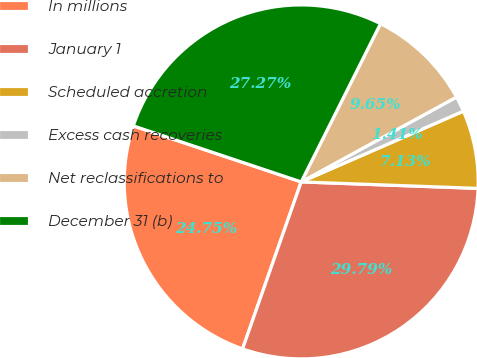<chart> <loc_0><loc_0><loc_500><loc_500><pie_chart><fcel>In millions<fcel>January 1<fcel>Scheduled accretion<fcel>Excess cash recoveries<fcel>Net reclassifications to<fcel>December 31 (b)<nl><fcel>24.75%<fcel>29.79%<fcel>7.13%<fcel>1.41%<fcel>9.65%<fcel>27.27%<nl></chart> 